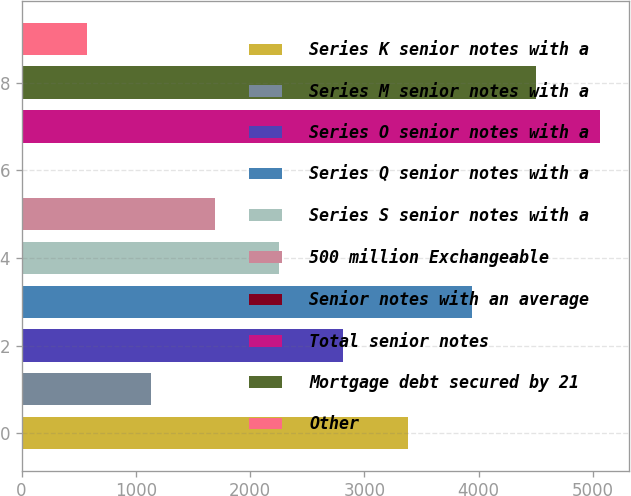Convert chart to OTSL. <chart><loc_0><loc_0><loc_500><loc_500><bar_chart><fcel>Series K senior notes with a<fcel>Series M senior notes with a<fcel>Series O senior notes with a<fcel>Series Q senior notes with a<fcel>Series S senior notes with a<fcel>500 million Exchangeable<fcel>Senior notes with an average<fcel>Total senior notes<fcel>Mortgage debt secured by 21<fcel>Other<nl><fcel>3377.8<fcel>1130.6<fcel>2816<fcel>3939.6<fcel>2254.2<fcel>1692.4<fcel>7<fcel>5063.2<fcel>4501.4<fcel>568.8<nl></chart> 